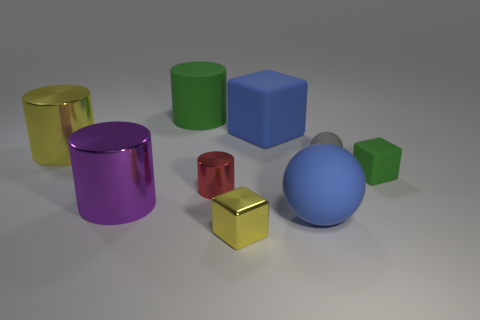What shape is the tiny object that is the same color as the rubber cylinder?
Offer a terse response. Cube. Is the number of tiny cylinders greater than the number of gray shiny spheres?
Ensure brevity in your answer.  Yes. Are there more yellow cylinders to the right of the big green cylinder than blue rubber blocks that are to the right of the large block?
Make the answer very short. No. What size is the matte thing that is behind the large yellow shiny cylinder and to the right of the big rubber cylinder?
Give a very brief answer. Large. What number of gray matte balls are the same size as the red cylinder?
Offer a very short reply. 1. What is the material of the object that is the same color as the big rubber cylinder?
Your response must be concise. Rubber. There is a yellow object that is on the left side of the large green matte cylinder; is it the same shape as the tiny red metal thing?
Keep it short and to the point. Yes. Is the number of big yellow metal cylinders right of the small red metal cylinder less than the number of small matte balls?
Make the answer very short. Yes. Is there a tiny shiny block that has the same color as the big rubber sphere?
Your answer should be very brief. No. There is a red thing; is its shape the same as the blue matte object that is right of the blue rubber cube?
Your answer should be very brief. No. 